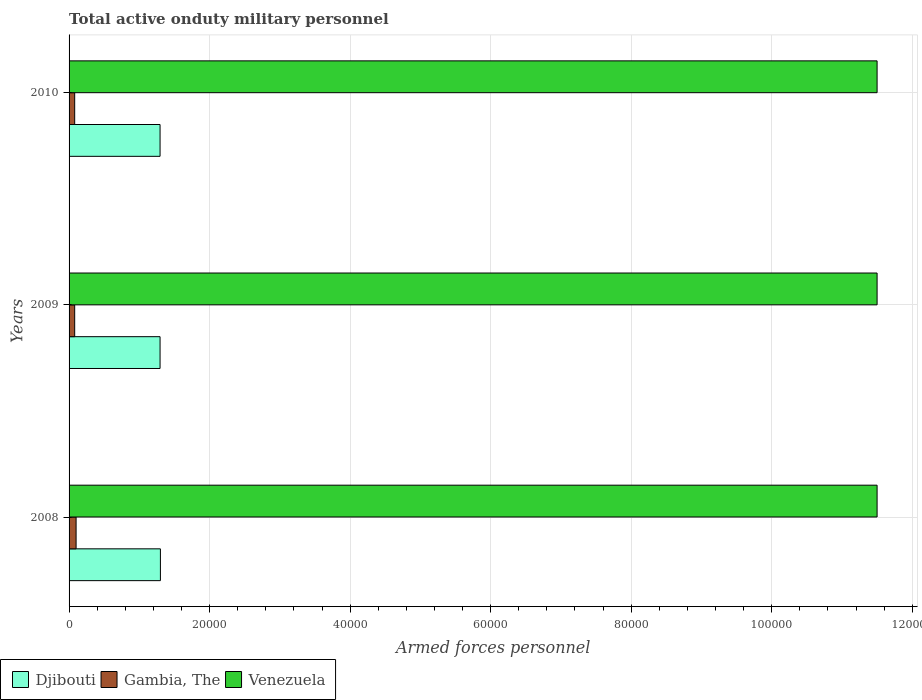How many groups of bars are there?
Your response must be concise. 3. How many bars are there on the 3rd tick from the top?
Keep it short and to the point. 3. In how many cases, is the number of bars for a given year not equal to the number of legend labels?
Your answer should be compact. 0. What is the number of armed forces personnel in Venezuela in 2009?
Provide a succinct answer. 1.15e+05. Across all years, what is the maximum number of armed forces personnel in Venezuela?
Your response must be concise. 1.15e+05. Across all years, what is the minimum number of armed forces personnel in Venezuela?
Make the answer very short. 1.15e+05. In which year was the number of armed forces personnel in Djibouti minimum?
Keep it short and to the point. 2009. What is the total number of armed forces personnel in Venezuela in the graph?
Keep it short and to the point. 3.45e+05. What is the difference between the number of armed forces personnel in Gambia, The in 2010 and the number of armed forces personnel in Djibouti in 2008?
Your response must be concise. -1.22e+04. What is the average number of armed forces personnel in Venezuela per year?
Make the answer very short. 1.15e+05. In the year 2009, what is the difference between the number of armed forces personnel in Gambia, The and number of armed forces personnel in Djibouti?
Offer a very short reply. -1.22e+04. What is the ratio of the number of armed forces personnel in Venezuela in 2008 to that in 2009?
Make the answer very short. 1. What is the difference between the highest and the second highest number of armed forces personnel in Djibouti?
Ensure brevity in your answer.  50. In how many years, is the number of armed forces personnel in Djibouti greater than the average number of armed forces personnel in Djibouti taken over all years?
Give a very brief answer. 1. Is the sum of the number of armed forces personnel in Djibouti in 2008 and 2009 greater than the maximum number of armed forces personnel in Gambia, The across all years?
Keep it short and to the point. Yes. What does the 3rd bar from the top in 2010 represents?
Make the answer very short. Djibouti. What does the 1st bar from the bottom in 2009 represents?
Provide a succinct answer. Djibouti. How many bars are there?
Your answer should be compact. 9. Are all the bars in the graph horizontal?
Your answer should be compact. Yes. How many years are there in the graph?
Your answer should be very brief. 3. What is the difference between two consecutive major ticks on the X-axis?
Provide a short and direct response. 2.00e+04. Are the values on the major ticks of X-axis written in scientific E-notation?
Your answer should be compact. No. Does the graph contain any zero values?
Provide a short and direct response. No. Does the graph contain grids?
Your answer should be compact. Yes. Where does the legend appear in the graph?
Provide a short and direct response. Bottom left. How many legend labels are there?
Keep it short and to the point. 3. How are the legend labels stacked?
Give a very brief answer. Horizontal. What is the title of the graph?
Make the answer very short. Total active onduty military personnel. What is the label or title of the X-axis?
Provide a succinct answer. Armed forces personnel. What is the label or title of the Y-axis?
Offer a terse response. Years. What is the Armed forces personnel in Djibouti in 2008?
Your answer should be very brief. 1.30e+04. What is the Armed forces personnel of Venezuela in 2008?
Provide a short and direct response. 1.15e+05. What is the Armed forces personnel in Djibouti in 2009?
Offer a very short reply. 1.30e+04. What is the Armed forces personnel in Gambia, The in 2009?
Make the answer very short. 800. What is the Armed forces personnel in Venezuela in 2009?
Your answer should be very brief. 1.15e+05. What is the Armed forces personnel of Djibouti in 2010?
Keep it short and to the point. 1.30e+04. What is the Armed forces personnel in Gambia, The in 2010?
Make the answer very short. 800. What is the Armed forces personnel of Venezuela in 2010?
Your response must be concise. 1.15e+05. Across all years, what is the maximum Armed forces personnel of Djibouti?
Offer a very short reply. 1.30e+04. Across all years, what is the maximum Armed forces personnel in Venezuela?
Give a very brief answer. 1.15e+05. Across all years, what is the minimum Armed forces personnel of Djibouti?
Your answer should be very brief. 1.30e+04. Across all years, what is the minimum Armed forces personnel in Gambia, The?
Your response must be concise. 800. Across all years, what is the minimum Armed forces personnel in Venezuela?
Provide a short and direct response. 1.15e+05. What is the total Armed forces personnel of Djibouti in the graph?
Ensure brevity in your answer.  3.89e+04. What is the total Armed forces personnel in Gambia, The in the graph?
Offer a terse response. 2600. What is the total Armed forces personnel in Venezuela in the graph?
Provide a succinct answer. 3.45e+05. What is the difference between the Armed forces personnel of Djibouti in 2008 and that in 2010?
Keep it short and to the point. 50. What is the difference between the Armed forces personnel of Venezuela in 2009 and that in 2010?
Provide a succinct answer. 0. What is the difference between the Armed forces personnel of Djibouti in 2008 and the Armed forces personnel of Gambia, The in 2009?
Offer a very short reply. 1.22e+04. What is the difference between the Armed forces personnel in Djibouti in 2008 and the Armed forces personnel in Venezuela in 2009?
Offer a very short reply. -1.02e+05. What is the difference between the Armed forces personnel of Gambia, The in 2008 and the Armed forces personnel of Venezuela in 2009?
Offer a very short reply. -1.14e+05. What is the difference between the Armed forces personnel of Djibouti in 2008 and the Armed forces personnel of Gambia, The in 2010?
Give a very brief answer. 1.22e+04. What is the difference between the Armed forces personnel in Djibouti in 2008 and the Armed forces personnel in Venezuela in 2010?
Offer a very short reply. -1.02e+05. What is the difference between the Armed forces personnel in Gambia, The in 2008 and the Armed forces personnel in Venezuela in 2010?
Keep it short and to the point. -1.14e+05. What is the difference between the Armed forces personnel in Djibouti in 2009 and the Armed forces personnel in Gambia, The in 2010?
Make the answer very short. 1.22e+04. What is the difference between the Armed forces personnel of Djibouti in 2009 and the Armed forces personnel of Venezuela in 2010?
Give a very brief answer. -1.02e+05. What is the difference between the Armed forces personnel of Gambia, The in 2009 and the Armed forces personnel of Venezuela in 2010?
Provide a short and direct response. -1.14e+05. What is the average Armed forces personnel in Djibouti per year?
Provide a succinct answer. 1.30e+04. What is the average Armed forces personnel in Gambia, The per year?
Ensure brevity in your answer.  866.67. What is the average Armed forces personnel in Venezuela per year?
Your answer should be compact. 1.15e+05. In the year 2008, what is the difference between the Armed forces personnel in Djibouti and Armed forces personnel in Gambia, The?
Provide a short and direct response. 1.20e+04. In the year 2008, what is the difference between the Armed forces personnel in Djibouti and Armed forces personnel in Venezuela?
Offer a very short reply. -1.02e+05. In the year 2008, what is the difference between the Armed forces personnel of Gambia, The and Armed forces personnel of Venezuela?
Your answer should be very brief. -1.14e+05. In the year 2009, what is the difference between the Armed forces personnel in Djibouti and Armed forces personnel in Gambia, The?
Give a very brief answer. 1.22e+04. In the year 2009, what is the difference between the Armed forces personnel of Djibouti and Armed forces personnel of Venezuela?
Provide a short and direct response. -1.02e+05. In the year 2009, what is the difference between the Armed forces personnel in Gambia, The and Armed forces personnel in Venezuela?
Provide a short and direct response. -1.14e+05. In the year 2010, what is the difference between the Armed forces personnel in Djibouti and Armed forces personnel in Gambia, The?
Give a very brief answer. 1.22e+04. In the year 2010, what is the difference between the Armed forces personnel in Djibouti and Armed forces personnel in Venezuela?
Make the answer very short. -1.02e+05. In the year 2010, what is the difference between the Armed forces personnel in Gambia, The and Armed forces personnel in Venezuela?
Offer a very short reply. -1.14e+05. What is the ratio of the Armed forces personnel of Gambia, The in 2008 to that in 2009?
Keep it short and to the point. 1.25. What is the ratio of the Armed forces personnel in Venezuela in 2008 to that in 2010?
Make the answer very short. 1. What is the ratio of the Armed forces personnel in Gambia, The in 2009 to that in 2010?
Offer a very short reply. 1. What is the difference between the highest and the second highest Armed forces personnel of Djibouti?
Keep it short and to the point. 50. What is the difference between the highest and the second highest Armed forces personnel of Gambia, The?
Offer a terse response. 200. What is the difference between the highest and the second highest Armed forces personnel in Venezuela?
Make the answer very short. 0. What is the difference between the highest and the lowest Armed forces personnel in Venezuela?
Offer a very short reply. 0. 